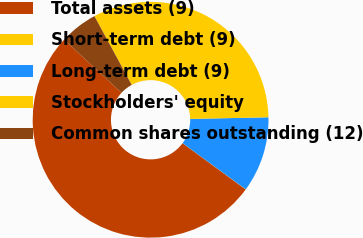Convert chart to OTSL. <chart><loc_0><loc_0><loc_500><loc_500><pie_chart><fcel>Total assets (9)<fcel>Short-term debt (9)<fcel>Long-term debt (9)<fcel>Stockholders' equity<fcel>Common shares outstanding (12)<nl><fcel>51.82%<fcel>0.02%<fcel>10.38%<fcel>32.57%<fcel>5.2%<nl></chart> 